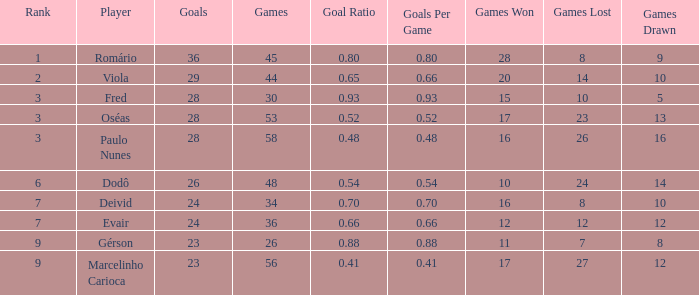Would you mind parsing the complete table? {'header': ['Rank', 'Player', 'Goals', 'Games', 'Goal Ratio', 'Goals Per Game', 'Games Won', 'Games Lost', 'Games Drawn'], 'rows': [['1', 'Romário', '36', '45', '0.80', '0.80', '28', '8', '9'], ['2', 'Viola', '29', '44', '0.65', '0.66', '20', '14', '10'], ['3', 'Fred', '28', '30', '0.93', '0.93', '15', '10', '5'], ['3', 'Oséas', '28', '53', '0.52', '0.52', '17', '23', '13'], ['3', 'Paulo Nunes', '28', '58', '0.48', '0.48', '16', '26', '16'], ['6', 'Dodô', '26', '48', '0.54', '0.54', '10', '24', '14'], ['7', 'Deivid', '24', '34', '0.70', '0.70', '16', '8', '10'], ['7', 'Evair', '24', '36', '0.66', '0.66', '12', '12', '12'], ['9', 'Gérson', '23', '26', '0.88', '0.88', '11', '7', '8'], ['9', 'Marcelinho Carioca', '23', '56', '0.41', '0.41', '17', '27', '12']]} How many goals have a goal ration less than 0.8 with 56 games? 1.0. 